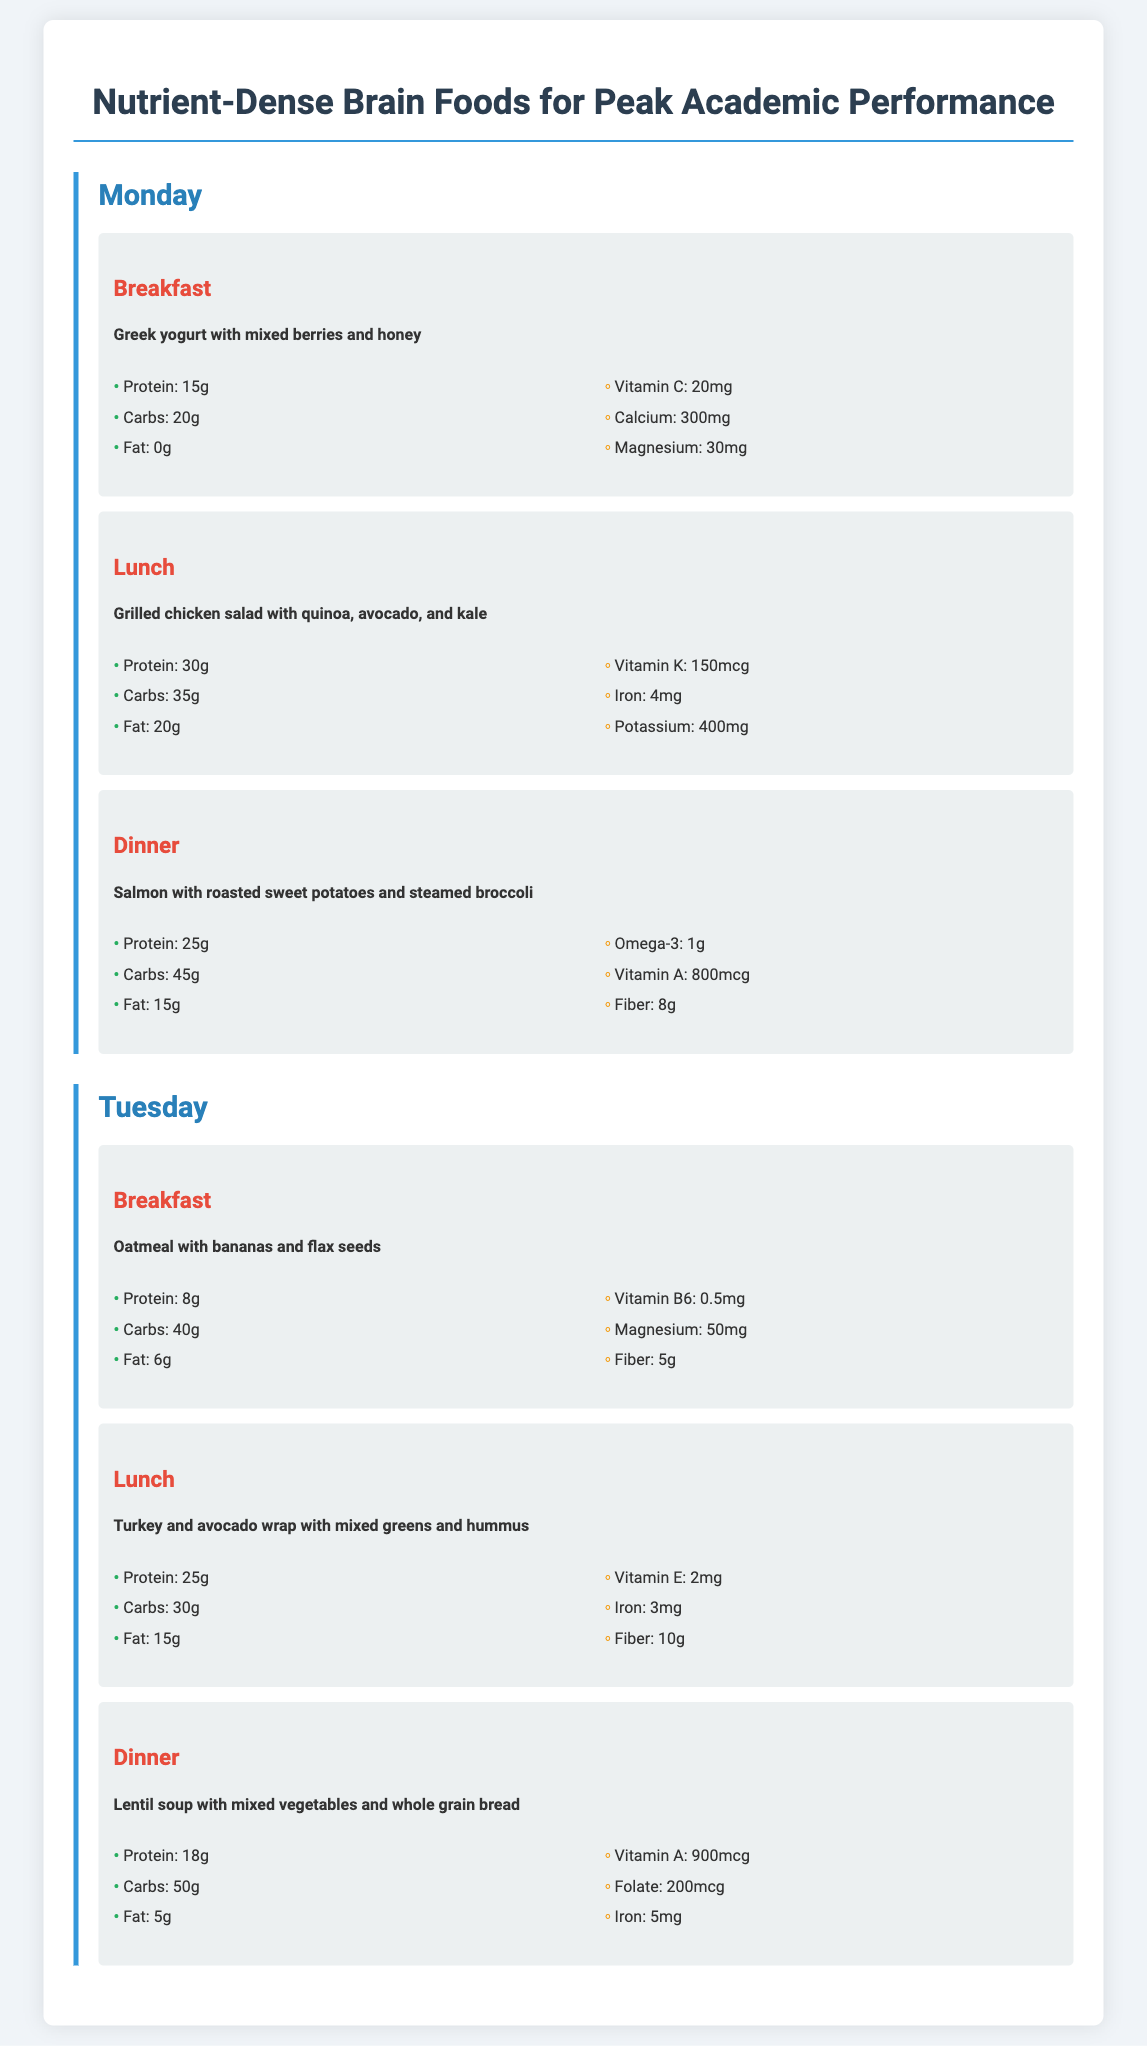What is in the breakfast for Monday? The breakfast for Monday includes Greek yogurt with mixed berries and honey.
Answer: Greek yogurt with mixed berries and honey How much protein is in the lunch for Tuesday? The protein content in the Tuesday lunch is specified as 25g.
Answer: 25g What is the fat content of the dinner on Monday? The fat content of the dinner on Monday is listed as 15g.
Answer: 15g Which meal includes oatmeal? The meal that includes oatmeal is breakfast on Tuesday.
Answer: Breakfast on Tuesday What vitamin is high in the grilled chicken salad? The grilled chicken salad is high in Vitamin K with a content of 150mcg.
Answer: Vitamin K How much fiber is present in the lentil soup for Tuesday? The lentil soup contains 10g of fiber, as listed in the document.
Answer: 10g What is the main protein source for dinner on Monday? The main protein source for dinner on Monday is salmon.
Answer: Salmon How many meals are listed for Monday? There are three meals listed for Monday: breakfast, lunch, and dinner.
Answer: Three meals What is the total carbohydrate content in the grilled chicken salad? The carbohydrate content in the grilled chicken salad is stated as 35g.
Answer: 35g 